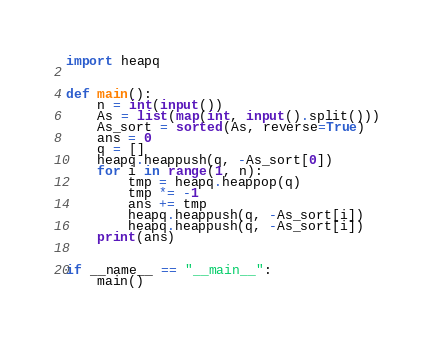<code> <loc_0><loc_0><loc_500><loc_500><_Python_>import heapq


def main():
    n = int(input())
    As = list(map(int, input().split()))
    As_sort = sorted(As, reverse=True)
    ans = 0
    q = []
    heapq.heappush(q, -As_sort[0])
    for i in range(1, n):
        tmp = heapq.heappop(q)
        tmp *= -1
        ans += tmp
        heapq.heappush(q, -As_sort[i])
        heapq.heappush(q, -As_sort[i])
    print(ans)


if __name__ == "__main__":
    main()
</code> 